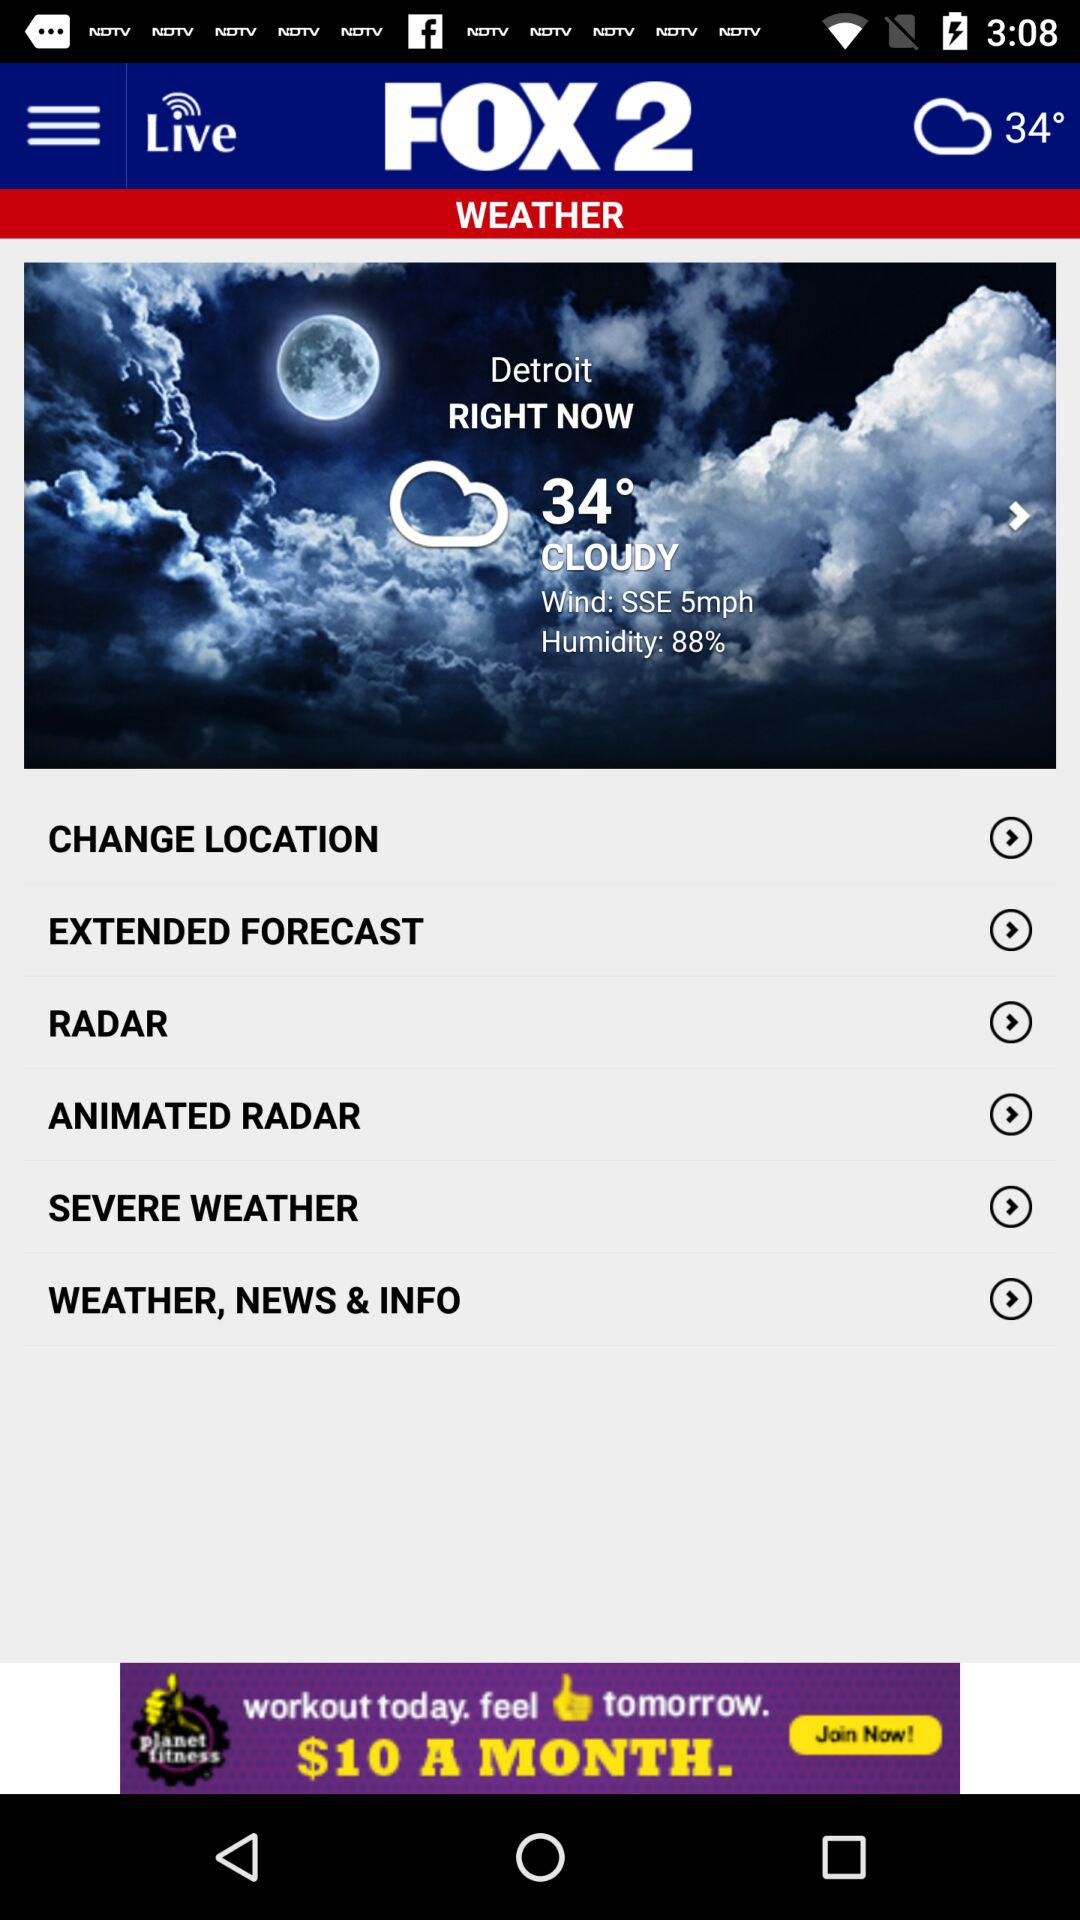What is the temperature? The temperature is 34°. 